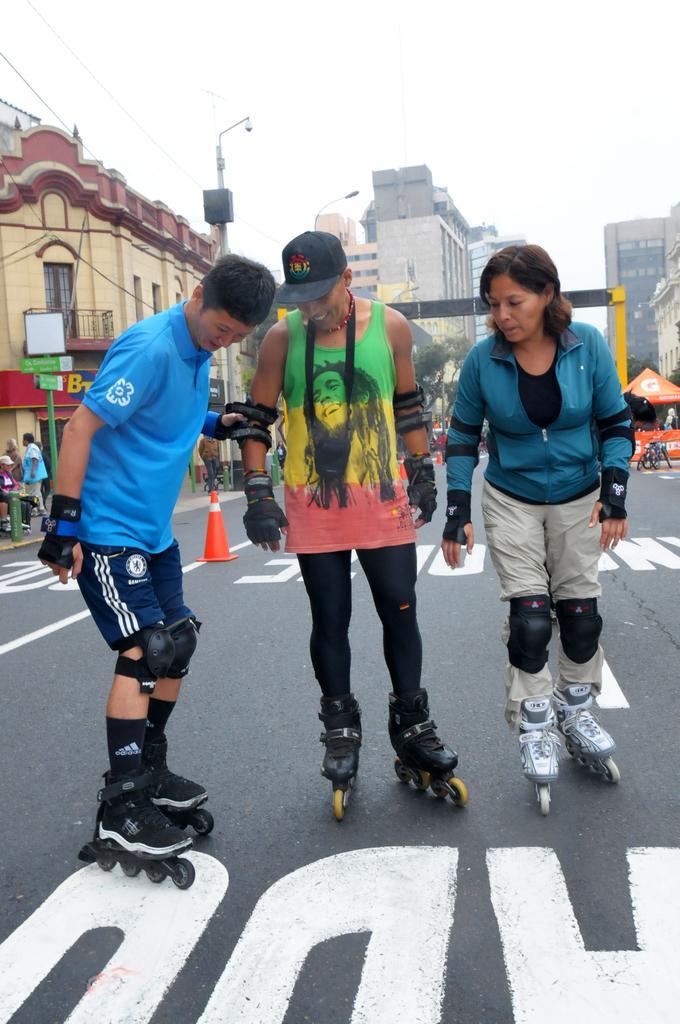In one or two sentences, can you explain what this image depicts? In this image we can see some persons wearing skates are standing on the ground. To the right side of the image we can see bicycle parked on road ,a tent. In the background we can see a person standing , group of buildings with windows ,metal barricades,cone,pole with CCTV camera and the sky 